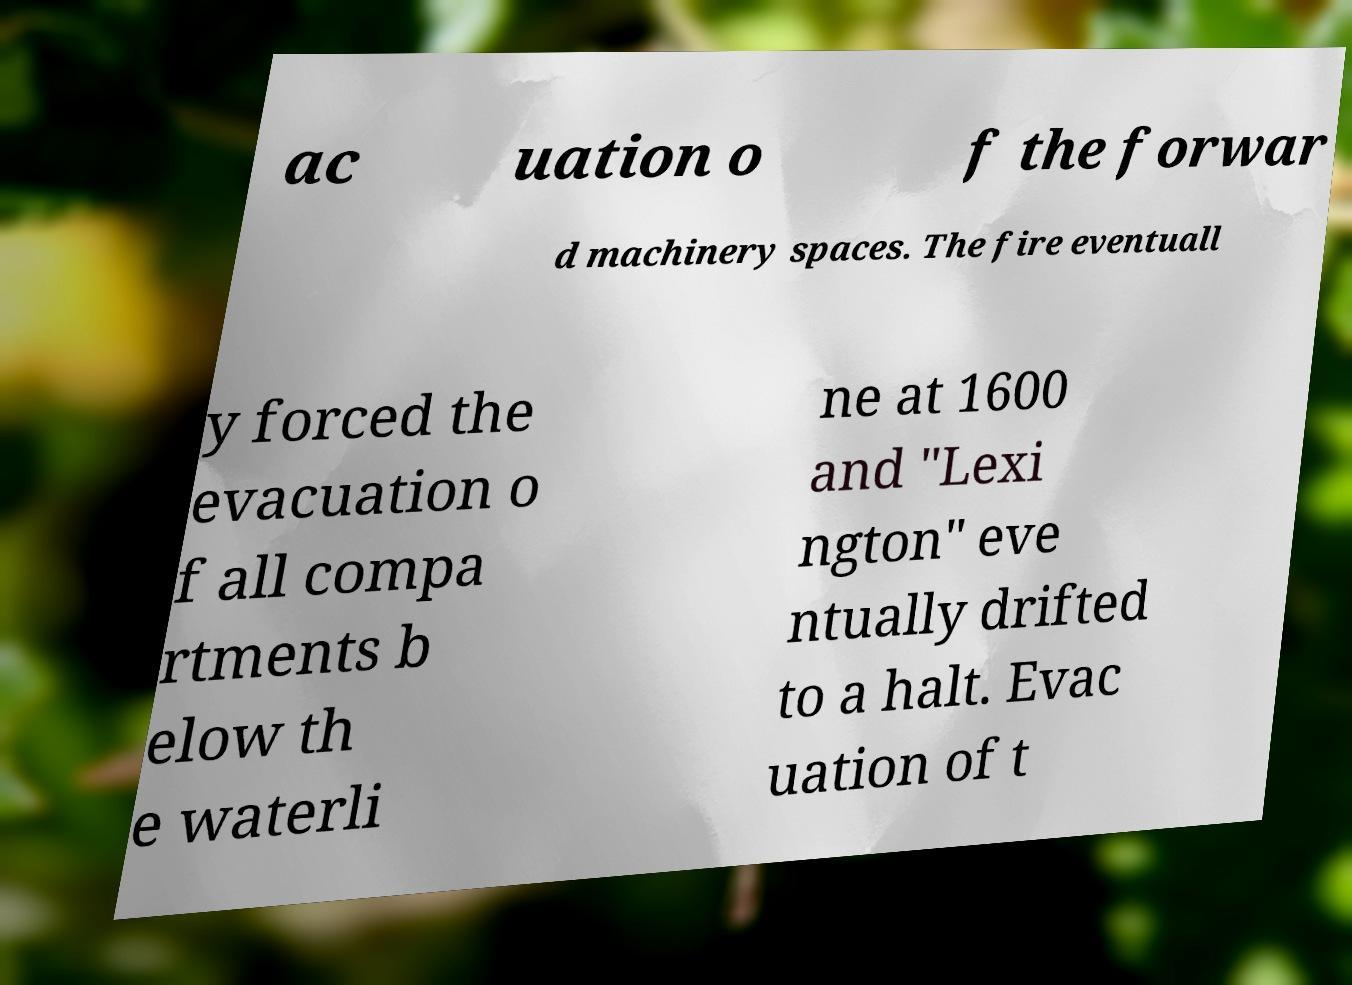Could you assist in decoding the text presented in this image and type it out clearly? ac uation o f the forwar d machinery spaces. The fire eventuall y forced the evacuation o f all compa rtments b elow th e waterli ne at 1600 and "Lexi ngton" eve ntually drifted to a halt. Evac uation of t 